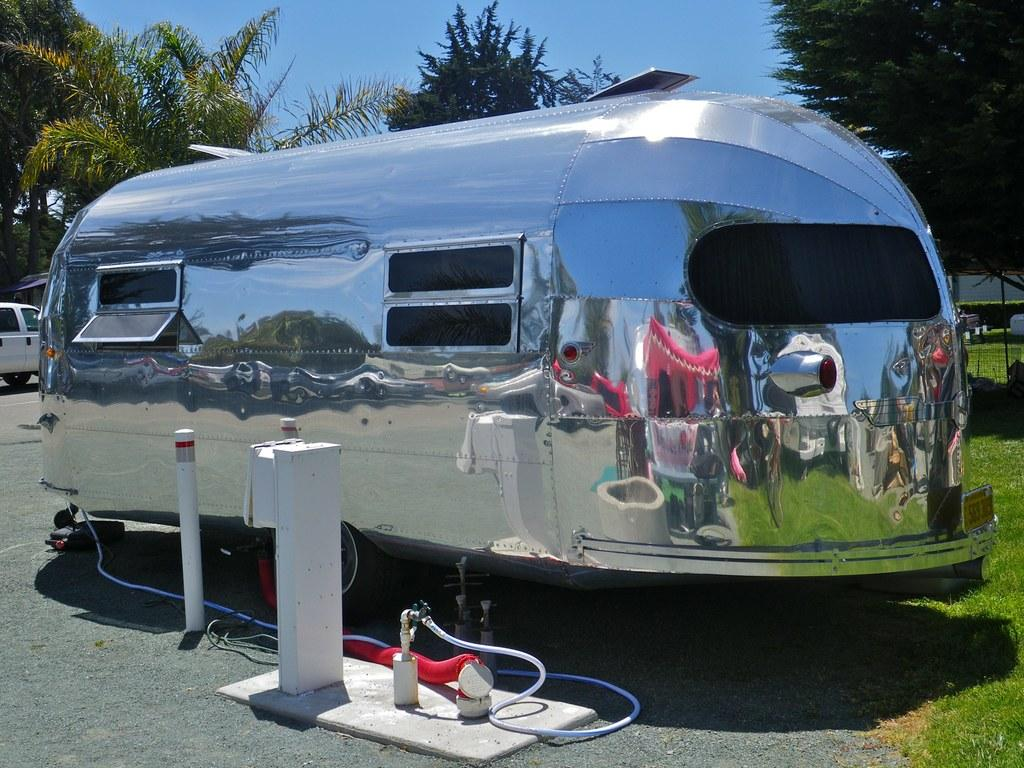What is the main subject in the center of the image? There is a travel trailer in the center of the image. What can be seen at the top side of the image? There are plants at the top side of the image. What type of skirt is the travel trailer wearing in the image? Travel trailers do not wear skirts; they are inanimate objects. 